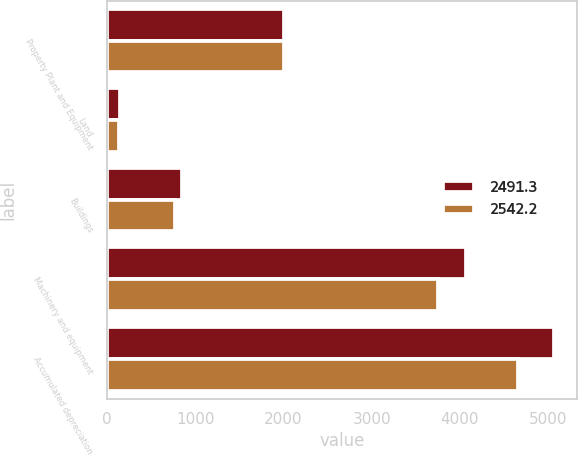Convert chart to OTSL. <chart><loc_0><loc_0><loc_500><loc_500><stacked_bar_chart><ecel><fcel>Property Plant and Equipment<fcel>Land<fcel>Buildings<fcel>Machinery and equipment<fcel>Accumulated depreciation<nl><fcel>2491.3<fcel>2003<fcel>142.2<fcel>853<fcel>4074<fcel>5069.2<nl><fcel>2542.2<fcel>2002<fcel>132.7<fcel>771.8<fcel>3752.4<fcel>4656.9<nl></chart> 